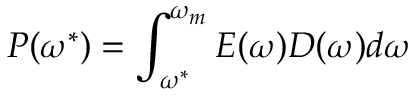Convert formula to latex. <formula><loc_0><loc_0><loc_500><loc_500>P ( \omega ^ { * } ) = \int _ { \omega ^ { * } } ^ { \omega _ { m } } E ( \omega ) D ( \omega ) d \omega</formula> 